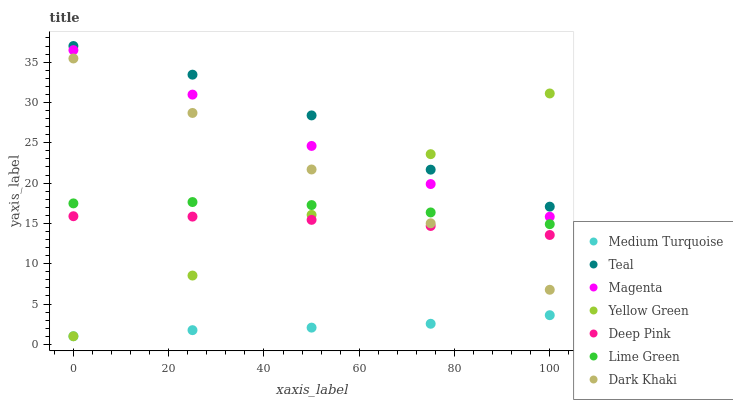Does Medium Turquoise have the minimum area under the curve?
Answer yes or no. Yes. Does Teal have the maximum area under the curve?
Answer yes or no. Yes. Does Dark Khaki have the minimum area under the curve?
Answer yes or no. No. Does Dark Khaki have the maximum area under the curve?
Answer yes or no. No. Is Yellow Green the smoothest?
Answer yes or no. Yes. Is Teal the roughest?
Answer yes or no. Yes. Is Medium Turquoise the smoothest?
Answer yes or no. No. Is Medium Turquoise the roughest?
Answer yes or no. No. Does Medium Turquoise have the lowest value?
Answer yes or no. Yes. Does Dark Khaki have the lowest value?
Answer yes or no. No. Does Teal have the highest value?
Answer yes or no. Yes. Does Dark Khaki have the highest value?
Answer yes or no. No. Is Medium Turquoise less than Deep Pink?
Answer yes or no. Yes. Is Magenta greater than Deep Pink?
Answer yes or no. Yes. Does Yellow Green intersect Lime Green?
Answer yes or no. Yes. Is Yellow Green less than Lime Green?
Answer yes or no. No. Is Yellow Green greater than Lime Green?
Answer yes or no. No. Does Medium Turquoise intersect Deep Pink?
Answer yes or no. No. 